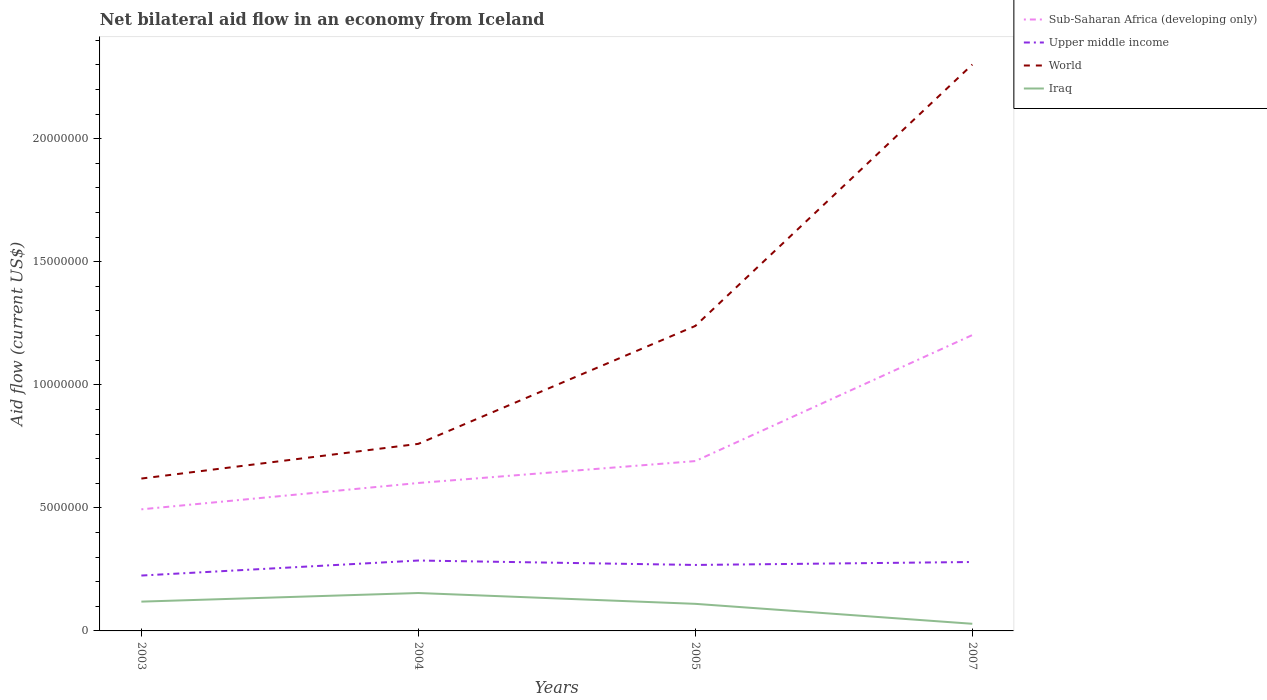How many different coloured lines are there?
Provide a succinct answer. 4. Across all years, what is the maximum net bilateral aid flow in Sub-Saharan Africa (developing only)?
Your answer should be very brief. 4.94e+06. In which year was the net bilateral aid flow in Iraq maximum?
Keep it short and to the point. 2007. What is the total net bilateral aid flow in Iraq in the graph?
Provide a short and direct response. -3.50e+05. What is the difference between the highest and the second highest net bilateral aid flow in Sub-Saharan Africa (developing only)?
Your response must be concise. 7.08e+06. What is the difference between the highest and the lowest net bilateral aid flow in Iraq?
Make the answer very short. 3. Is the net bilateral aid flow in Sub-Saharan Africa (developing only) strictly greater than the net bilateral aid flow in Iraq over the years?
Provide a short and direct response. No. Does the graph contain any zero values?
Your response must be concise. No. Does the graph contain grids?
Provide a succinct answer. No. How many legend labels are there?
Provide a succinct answer. 4. How are the legend labels stacked?
Your answer should be compact. Vertical. What is the title of the graph?
Provide a succinct answer. Net bilateral aid flow in an economy from Iceland. Does "Bangladesh" appear as one of the legend labels in the graph?
Your response must be concise. No. What is the label or title of the Y-axis?
Keep it short and to the point. Aid flow (current US$). What is the Aid flow (current US$) in Sub-Saharan Africa (developing only) in 2003?
Provide a short and direct response. 4.94e+06. What is the Aid flow (current US$) in Upper middle income in 2003?
Your answer should be very brief. 2.25e+06. What is the Aid flow (current US$) in World in 2003?
Your answer should be very brief. 6.19e+06. What is the Aid flow (current US$) in Iraq in 2003?
Your answer should be very brief. 1.19e+06. What is the Aid flow (current US$) of Sub-Saharan Africa (developing only) in 2004?
Provide a succinct answer. 6.01e+06. What is the Aid flow (current US$) of Upper middle income in 2004?
Provide a succinct answer. 2.86e+06. What is the Aid flow (current US$) of World in 2004?
Provide a short and direct response. 7.60e+06. What is the Aid flow (current US$) in Iraq in 2004?
Ensure brevity in your answer.  1.54e+06. What is the Aid flow (current US$) of Sub-Saharan Africa (developing only) in 2005?
Provide a short and direct response. 6.90e+06. What is the Aid flow (current US$) in Upper middle income in 2005?
Your answer should be very brief. 2.68e+06. What is the Aid flow (current US$) in World in 2005?
Your answer should be compact. 1.24e+07. What is the Aid flow (current US$) in Iraq in 2005?
Make the answer very short. 1.10e+06. What is the Aid flow (current US$) of Sub-Saharan Africa (developing only) in 2007?
Provide a succinct answer. 1.20e+07. What is the Aid flow (current US$) of Upper middle income in 2007?
Your answer should be very brief. 2.80e+06. What is the Aid flow (current US$) of World in 2007?
Offer a very short reply. 2.30e+07. Across all years, what is the maximum Aid flow (current US$) in Sub-Saharan Africa (developing only)?
Keep it short and to the point. 1.20e+07. Across all years, what is the maximum Aid flow (current US$) of Upper middle income?
Your answer should be very brief. 2.86e+06. Across all years, what is the maximum Aid flow (current US$) in World?
Provide a succinct answer. 2.30e+07. Across all years, what is the maximum Aid flow (current US$) in Iraq?
Your answer should be compact. 1.54e+06. Across all years, what is the minimum Aid flow (current US$) in Sub-Saharan Africa (developing only)?
Keep it short and to the point. 4.94e+06. Across all years, what is the minimum Aid flow (current US$) of Upper middle income?
Offer a terse response. 2.25e+06. Across all years, what is the minimum Aid flow (current US$) in World?
Provide a short and direct response. 6.19e+06. Across all years, what is the minimum Aid flow (current US$) of Iraq?
Keep it short and to the point. 2.90e+05. What is the total Aid flow (current US$) of Sub-Saharan Africa (developing only) in the graph?
Provide a short and direct response. 2.99e+07. What is the total Aid flow (current US$) in Upper middle income in the graph?
Your answer should be very brief. 1.06e+07. What is the total Aid flow (current US$) in World in the graph?
Offer a terse response. 4.92e+07. What is the total Aid flow (current US$) of Iraq in the graph?
Offer a terse response. 4.12e+06. What is the difference between the Aid flow (current US$) of Sub-Saharan Africa (developing only) in 2003 and that in 2004?
Keep it short and to the point. -1.07e+06. What is the difference between the Aid flow (current US$) in Upper middle income in 2003 and that in 2004?
Offer a very short reply. -6.10e+05. What is the difference between the Aid flow (current US$) of World in 2003 and that in 2004?
Provide a succinct answer. -1.41e+06. What is the difference between the Aid flow (current US$) of Iraq in 2003 and that in 2004?
Ensure brevity in your answer.  -3.50e+05. What is the difference between the Aid flow (current US$) in Sub-Saharan Africa (developing only) in 2003 and that in 2005?
Offer a very short reply. -1.96e+06. What is the difference between the Aid flow (current US$) in Upper middle income in 2003 and that in 2005?
Your response must be concise. -4.30e+05. What is the difference between the Aid flow (current US$) in World in 2003 and that in 2005?
Provide a succinct answer. -6.20e+06. What is the difference between the Aid flow (current US$) in Sub-Saharan Africa (developing only) in 2003 and that in 2007?
Offer a terse response. -7.08e+06. What is the difference between the Aid flow (current US$) in Upper middle income in 2003 and that in 2007?
Keep it short and to the point. -5.50e+05. What is the difference between the Aid flow (current US$) of World in 2003 and that in 2007?
Ensure brevity in your answer.  -1.68e+07. What is the difference between the Aid flow (current US$) of Sub-Saharan Africa (developing only) in 2004 and that in 2005?
Make the answer very short. -8.90e+05. What is the difference between the Aid flow (current US$) in Upper middle income in 2004 and that in 2005?
Your response must be concise. 1.80e+05. What is the difference between the Aid flow (current US$) in World in 2004 and that in 2005?
Make the answer very short. -4.79e+06. What is the difference between the Aid flow (current US$) in Iraq in 2004 and that in 2005?
Provide a succinct answer. 4.40e+05. What is the difference between the Aid flow (current US$) in Sub-Saharan Africa (developing only) in 2004 and that in 2007?
Make the answer very short. -6.01e+06. What is the difference between the Aid flow (current US$) in World in 2004 and that in 2007?
Give a very brief answer. -1.54e+07. What is the difference between the Aid flow (current US$) in Iraq in 2004 and that in 2007?
Your response must be concise. 1.25e+06. What is the difference between the Aid flow (current US$) in Sub-Saharan Africa (developing only) in 2005 and that in 2007?
Give a very brief answer. -5.12e+06. What is the difference between the Aid flow (current US$) of World in 2005 and that in 2007?
Offer a terse response. -1.06e+07. What is the difference between the Aid flow (current US$) in Iraq in 2005 and that in 2007?
Make the answer very short. 8.10e+05. What is the difference between the Aid flow (current US$) of Sub-Saharan Africa (developing only) in 2003 and the Aid flow (current US$) of Upper middle income in 2004?
Give a very brief answer. 2.08e+06. What is the difference between the Aid flow (current US$) in Sub-Saharan Africa (developing only) in 2003 and the Aid flow (current US$) in World in 2004?
Provide a succinct answer. -2.66e+06. What is the difference between the Aid flow (current US$) in Sub-Saharan Africa (developing only) in 2003 and the Aid flow (current US$) in Iraq in 2004?
Offer a very short reply. 3.40e+06. What is the difference between the Aid flow (current US$) in Upper middle income in 2003 and the Aid flow (current US$) in World in 2004?
Provide a short and direct response. -5.35e+06. What is the difference between the Aid flow (current US$) in Upper middle income in 2003 and the Aid flow (current US$) in Iraq in 2004?
Keep it short and to the point. 7.10e+05. What is the difference between the Aid flow (current US$) of World in 2003 and the Aid flow (current US$) of Iraq in 2004?
Provide a succinct answer. 4.65e+06. What is the difference between the Aid flow (current US$) in Sub-Saharan Africa (developing only) in 2003 and the Aid flow (current US$) in Upper middle income in 2005?
Provide a succinct answer. 2.26e+06. What is the difference between the Aid flow (current US$) of Sub-Saharan Africa (developing only) in 2003 and the Aid flow (current US$) of World in 2005?
Keep it short and to the point. -7.45e+06. What is the difference between the Aid flow (current US$) in Sub-Saharan Africa (developing only) in 2003 and the Aid flow (current US$) in Iraq in 2005?
Make the answer very short. 3.84e+06. What is the difference between the Aid flow (current US$) in Upper middle income in 2003 and the Aid flow (current US$) in World in 2005?
Make the answer very short. -1.01e+07. What is the difference between the Aid flow (current US$) in Upper middle income in 2003 and the Aid flow (current US$) in Iraq in 2005?
Keep it short and to the point. 1.15e+06. What is the difference between the Aid flow (current US$) of World in 2003 and the Aid flow (current US$) of Iraq in 2005?
Ensure brevity in your answer.  5.09e+06. What is the difference between the Aid flow (current US$) of Sub-Saharan Africa (developing only) in 2003 and the Aid flow (current US$) of Upper middle income in 2007?
Offer a very short reply. 2.14e+06. What is the difference between the Aid flow (current US$) in Sub-Saharan Africa (developing only) in 2003 and the Aid flow (current US$) in World in 2007?
Give a very brief answer. -1.81e+07. What is the difference between the Aid flow (current US$) of Sub-Saharan Africa (developing only) in 2003 and the Aid flow (current US$) of Iraq in 2007?
Offer a very short reply. 4.65e+06. What is the difference between the Aid flow (current US$) in Upper middle income in 2003 and the Aid flow (current US$) in World in 2007?
Provide a succinct answer. -2.08e+07. What is the difference between the Aid flow (current US$) of Upper middle income in 2003 and the Aid flow (current US$) of Iraq in 2007?
Your answer should be very brief. 1.96e+06. What is the difference between the Aid flow (current US$) of World in 2003 and the Aid flow (current US$) of Iraq in 2007?
Ensure brevity in your answer.  5.90e+06. What is the difference between the Aid flow (current US$) of Sub-Saharan Africa (developing only) in 2004 and the Aid flow (current US$) of Upper middle income in 2005?
Your answer should be compact. 3.33e+06. What is the difference between the Aid flow (current US$) of Sub-Saharan Africa (developing only) in 2004 and the Aid flow (current US$) of World in 2005?
Offer a terse response. -6.38e+06. What is the difference between the Aid flow (current US$) of Sub-Saharan Africa (developing only) in 2004 and the Aid flow (current US$) of Iraq in 2005?
Your answer should be compact. 4.91e+06. What is the difference between the Aid flow (current US$) in Upper middle income in 2004 and the Aid flow (current US$) in World in 2005?
Ensure brevity in your answer.  -9.53e+06. What is the difference between the Aid flow (current US$) of Upper middle income in 2004 and the Aid flow (current US$) of Iraq in 2005?
Provide a short and direct response. 1.76e+06. What is the difference between the Aid flow (current US$) in World in 2004 and the Aid flow (current US$) in Iraq in 2005?
Offer a terse response. 6.50e+06. What is the difference between the Aid flow (current US$) in Sub-Saharan Africa (developing only) in 2004 and the Aid flow (current US$) in Upper middle income in 2007?
Provide a short and direct response. 3.21e+06. What is the difference between the Aid flow (current US$) of Sub-Saharan Africa (developing only) in 2004 and the Aid flow (current US$) of World in 2007?
Keep it short and to the point. -1.70e+07. What is the difference between the Aid flow (current US$) in Sub-Saharan Africa (developing only) in 2004 and the Aid flow (current US$) in Iraq in 2007?
Provide a short and direct response. 5.72e+06. What is the difference between the Aid flow (current US$) in Upper middle income in 2004 and the Aid flow (current US$) in World in 2007?
Provide a succinct answer. -2.02e+07. What is the difference between the Aid flow (current US$) in Upper middle income in 2004 and the Aid flow (current US$) in Iraq in 2007?
Ensure brevity in your answer.  2.57e+06. What is the difference between the Aid flow (current US$) in World in 2004 and the Aid flow (current US$) in Iraq in 2007?
Keep it short and to the point. 7.31e+06. What is the difference between the Aid flow (current US$) in Sub-Saharan Africa (developing only) in 2005 and the Aid flow (current US$) in Upper middle income in 2007?
Keep it short and to the point. 4.10e+06. What is the difference between the Aid flow (current US$) in Sub-Saharan Africa (developing only) in 2005 and the Aid flow (current US$) in World in 2007?
Provide a succinct answer. -1.61e+07. What is the difference between the Aid flow (current US$) in Sub-Saharan Africa (developing only) in 2005 and the Aid flow (current US$) in Iraq in 2007?
Give a very brief answer. 6.61e+06. What is the difference between the Aid flow (current US$) of Upper middle income in 2005 and the Aid flow (current US$) of World in 2007?
Your answer should be very brief. -2.03e+07. What is the difference between the Aid flow (current US$) in Upper middle income in 2005 and the Aid flow (current US$) in Iraq in 2007?
Keep it short and to the point. 2.39e+06. What is the difference between the Aid flow (current US$) in World in 2005 and the Aid flow (current US$) in Iraq in 2007?
Keep it short and to the point. 1.21e+07. What is the average Aid flow (current US$) in Sub-Saharan Africa (developing only) per year?
Your response must be concise. 7.47e+06. What is the average Aid flow (current US$) in Upper middle income per year?
Give a very brief answer. 2.65e+06. What is the average Aid flow (current US$) in World per year?
Your answer should be compact. 1.23e+07. What is the average Aid flow (current US$) in Iraq per year?
Provide a succinct answer. 1.03e+06. In the year 2003, what is the difference between the Aid flow (current US$) in Sub-Saharan Africa (developing only) and Aid flow (current US$) in Upper middle income?
Provide a short and direct response. 2.69e+06. In the year 2003, what is the difference between the Aid flow (current US$) of Sub-Saharan Africa (developing only) and Aid flow (current US$) of World?
Give a very brief answer. -1.25e+06. In the year 2003, what is the difference between the Aid flow (current US$) in Sub-Saharan Africa (developing only) and Aid flow (current US$) in Iraq?
Offer a terse response. 3.75e+06. In the year 2003, what is the difference between the Aid flow (current US$) in Upper middle income and Aid flow (current US$) in World?
Ensure brevity in your answer.  -3.94e+06. In the year 2003, what is the difference between the Aid flow (current US$) of Upper middle income and Aid flow (current US$) of Iraq?
Your answer should be very brief. 1.06e+06. In the year 2004, what is the difference between the Aid flow (current US$) in Sub-Saharan Africa (developing only) and Aid flow (current US$) in Upper middle income?
Offer a terse response. 3.15e+06. In the year 2004, what is the difference between the Aid flow (current US$) in Sub-Saharan Africa (developing only) and Aid flow (current US$) in World?
Offer a very short reply. -1.59e+06. In the year 2004, what is the difference between the Aid flow (current US$) in Sub-Saharan Africa (developing only) and Aid flow (current US$) in Iraq?
Provide a succinct answer. 4.47e+06. In the year 2004, what is the difference between the Aid flow (current US$) in Upper middle income and Aid flow (current US$) in World?
Provide a short and direct response. -4.74e+06. In the year 2004, what is the difference between the Aid flow (current US$) in Upper middle income and Aid flow (current US$) in Iraq?
Give a very brief answer. 1.32e+06. In the year 2004, what is the difference between the Aid flow (current US$) of World and Aid flow (current US$) of Iraq?
Make the answer very short. 6.06e+06. In the year 2005, what is the difference between the Aid flow (current US$) in Sub-Saharan Africa (developing only) and Aid flow (current US$) in Upper middle income?
Offer a terse response. 4.22e+06. In the year 2005, what is the difference between the Aid flow (current US$) in Sub-Saharan Africa (developing only) and Aid flow (current US$) in World?
Provide a succinct answer. -5.49e+06. In the year 2005, what is the difference between the Aid flow (current US$) in Sub-Saharan Africa (developing only) and Aid flow (current US$) in Iraq?
Provide a short and direct response. 5.80e+06. In the year 2005, what is the difference between the Aid flow (current US$) in Upper middle income and Aid flow (current US$) in World?
Give a very brief answer. -9.71e+06. In the year 2005, what is the difference between the Aid flow (current US$) of Upper middle income and Aid flow (current US$) of Iraq?
Provide a succinct answer. 1.58e+06. In the year 2005, what is the difference between the Aid flow (current US$) in World and Aid flow (current US$) in Iraq?
Give a very brief answer. 1.13e+07. In the year 2007, what is the difference between the Aid flow (current US$) in Sub-Saharan Africa (developing only) and Aid flow (current US$) in Upper middle income?
Make the answer very short. 9.22e+06. In the year 2007, what is the difference between the Aid flow (current US$) of Sub-Saharan Africa (developing only) and Aid flow (current US$) of World?
Offer a very short reply. -1.10e+07. In the year 2007, what is the difference between the Aid flow (current US$) of Sub-Saharan Africa (developing only) and Aid flow (current US$) of Iraq?
Ensure brevity in your answer.  1.17e+07. In the year 2007, what is the difference between the Aid flow (current US$) in Upper middle income and Aid flow (current US$) in World?
Provide a short and direct response. -2.02e+07. In the year 2007, what is the difference between the Aid flow (current US$) in Upper middle income and Aid flow (current US$) in Iraq?
Keep it short and to the point. 2.51e+06. In the year 2007, what is the difference between the Aid flow (current US$) in World and Aid flow (current US$) in Iraq?
Your answer should be compact. 2.27e+07. What is the ratio of the Aid flow (current US$) in Sub-Saharan Africa (developing only) in 2003 to that in 2004?
Your answer should be compact. 0.82. What is the ratio of the Aid flow (current US$) in Upper middle income in 2003 to that in 2004?
Offer a terse response. 0.79. What is the ratio of the Aid flow (current US$) of World in 2003 to that in 2004?
Give a very brief answer. 0.81. What is the ratio of the Aid flow (current US$) of Iraq in 2003 to that in 2004?
Your response must be concise. 0.77. What is the ratio of the Aid flow (current US$) of Sub-Saharan Africa (developing only) in 2003 to that in 2005?
Your answer should be very brief. 0.72. What is the ratio of the Aid flow (current US$) in Upper middle income in 2003 to that in 2005?
Your answer should be compact. 0.84. What is the ratio of the Aid flow (current US$) in World in 2003 to that in 2005?
Provide a short and direct response. 0.5. What is the ratio of the Aid flow (current US$) of Iraq in 2003 to that in 2005?
Your answer should be very brief. 1.08. What is the ratio of the Aid flow (current US$) of Sub-Saharan Africa (developing only) in 2003 to that in 2007?
Provide a succinct answer. 0.41. What is the ratio of the Aid flow (current US$) in Upper middle income in 2003 to that in 2007?
Offer a very short reply. 0.8. What is the ratio of the Aid flow (current US$) of World in 2003 to that in 2007?
Your answer should be compact. 0.27. What is the ratio of the Aid flow (current US$) of Iraq in 2003 to that in 2007?
Offer a terse response. 4.1. What is the ratio of the Aid flow (current US$) of Sub-Saharan Africa (developing only) in 2004 to that in 2005?
Make the answer very short. 0.87. What is the ratio of the Aid flow (current US$) in Upper middle income in 2004 to that in 2005?
Give a very brief answer. 1.07. What is the ratio of the Aid flow (current US$) in World in 2004 to that in 2005?
Make the answer very short. 0.61. What is the ratio of the Aid flow (current US$) of Iraq in 2004 to that in 2005?
Provide a short and direct response. 1.4. What is the ratio of the Aid flow (current US$) of Upper middle income in 2004 to that in 2007?
Your answer should be compact. 1.02. What is the ratio of the Aid flow (current US$) of World in 2004 to that in 2007?
Make the answer very short. 0.33. What is the ratio of the Aid flow (current US$) in Iraq in 2004 to that in 2007?
Offer a very short reply. 5.31. What is the ratio of the Aid flow (current US$) of Sub-Saharan Africa (developing only) in 2005 to that in 2007?
Offer a very short reply. 0.57. What is the ratio of the Aid flow (current US$) of Upper middle income in 2005 to that in 2007?
Ensure brevity in your answer.  0.96. What is the ratio of the Aid flow (current US$) in World in 2005 to that in 2007?
Offer a terse response. 0.54. What is the ratio of the Aid flow (current US$) of Iraq in 2005 to that in 2007?
Ensure brevity in your answer.  3.79. What is the difference between the highest and the second highest Aid flow (current US$) of Sub-Saharan Africa (developing only)?
Offer a terse response. 5.12e+06. What is the difference between the highest and the second highest Aid flow (current US$) in Upper middle income?
Your answer should be compact. 6.00e+04. What is the difference between the highest and the second highest Aid flow (current US$) in World?
Provide a short and direct response. 1.06e+07. What is the difference between the highest and the lowest Aid flow (current US$) of Sub-Saharan Africa (developing only)?
Offer a very short reply. 7.08e+06. What is the difference between the highest and the lowest Aid flow (current US$) of World?
Offer a terse response. 1.68e+07. What is the difference between the highest and the lowest Aid flow (current US$) in Iraq?
Make the answer very short. 1.25e+06. 